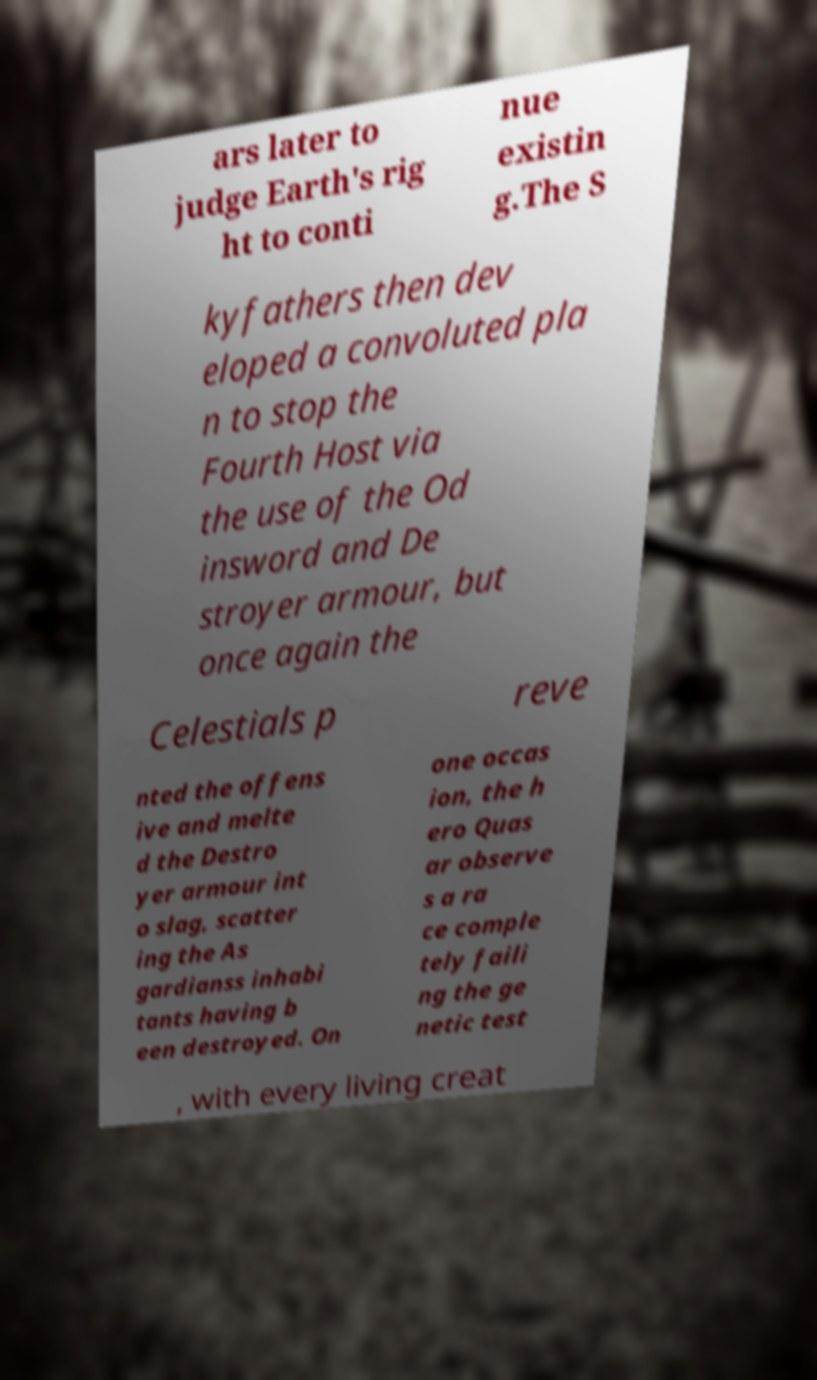I need the written content from this picture converted into text. Can you do that? ars later to judge Earth's rig ht to conti nue existin g.The S kyfathers then dev eloped a convoluted pla n to stop the Fourth Host via the use of the Od insword and De stroyer armour, but once again the Celestials p reve nted the offens ive and melte d the Destro yer armour int o slag, scatter ing the As gardianss inhabi tants having b een destroyed. On one occas ion, the h ero Quas ar observe s a ra ce comple tely faili ng the ge netic test , with every living creat 